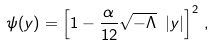Convert formula to latex. <formula><loc_0><loc_0><loc_500><loc_500>\psi ( y ) = \left [ 1 - \frac { \alpha } { 1 2 } \sqrt { - \Lambda } \ | y | \right ] ^ { 2 } \, ,</formula> 